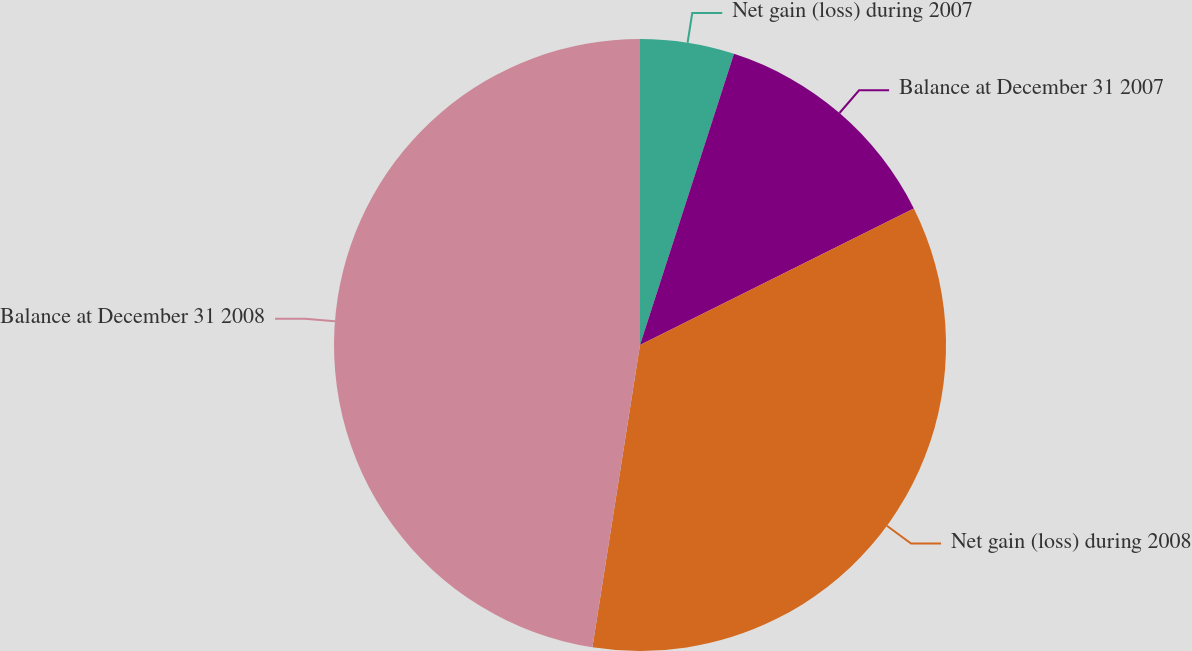Convert chart. <chart><loc_0><loc_0><loc_500><loc_500><pie_chart><fcel>Net gain (loss) during 2007<fcel>Balance at December 31 2007<fcel>Net gain (loss) during 2008<fcel>Balance at December 31 2008<nl><fcel>4.97%<fcel>12.67%<fcel>34.85%<fcel>47.52%<nl></chart> 